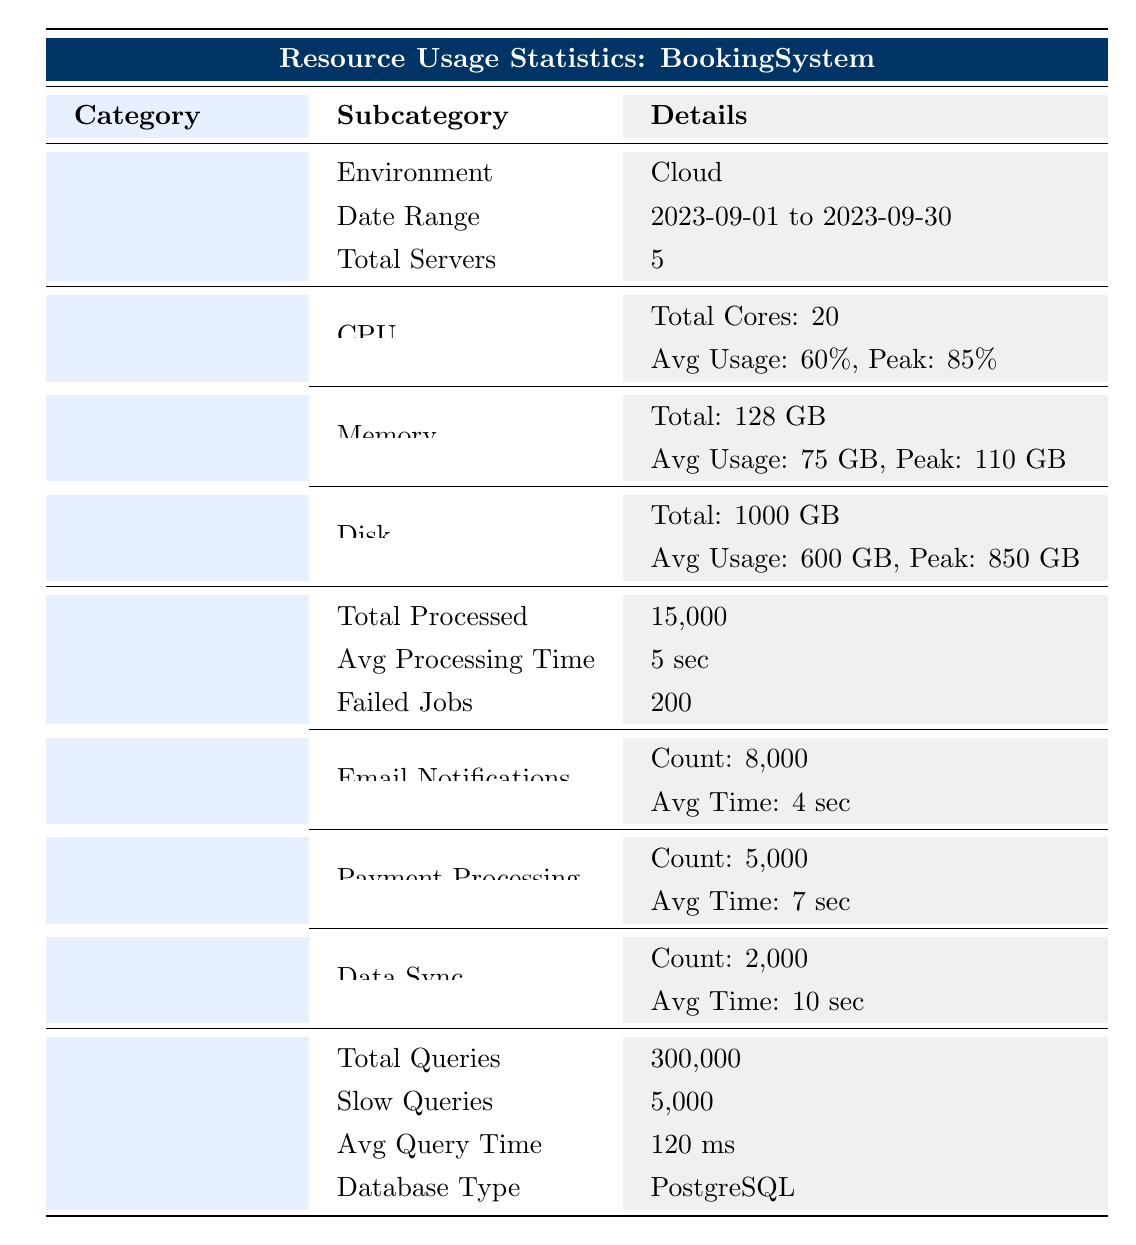What is the total number of servers used in the BookingSystem application? The table states under the "General Info" section that there are a total of 5 servers employed in the BookingSystem application.
Answer: 5 What is the average CPU usage in the BookingSystem application during September 2023? From the "Server Stats" section, the average CPU usage is displayed as 60%.
Answer: 60% How many failed background jobs were recorded? The table indicates in the "Background Jobs" section that there were 200 failed jobs throughout September 2023.
Answer: 200 What is the total memory usage in GB when peak memory usage is 110 GB and average memory usage is 75 GB? The peak usage is provided as 110 GB while the average usage is 75 GB. Since the question does not require combining these values, the answer is only about the peak usage noted in the table.
Answer: 110 Is the database type used in the BookingSystem application PostgreSQL? The "Database Stats" section confirms that the database type is specified as PostgreSQL.
Answer: Yes What is the total number of emails processed as background jobs? The "Job Types" section shows that the count for Email Notifications is 8000. Thus, this is the total number of emails processed.
Answer: 8000 What percentage of queries were slow based on the total queries and slow queries? The slow queries count is 5000, and total queries are 300000. Therefore, the percentage of slow queries is (5000 / 300000) * 100 = 1.67%. This requires calculating the ratio of slow queries to total queries.
Answer: 1.67% What is the average processing time for all background jobs? The average processing time for background jobs is mentioned in the table as 5 seconds, which is straightforward as found in the "Background Jobs" section.
Answer: 5 seconds Which job type took the longest average processing time? By comparing the average processing times across the job types listed in the "Job Types" section, Data Sync has the longest average processing time at 10 seconds.
Answer: Data Sync What is the peak disk usage in GB during September 2023? The "Disk" section in the "Server Stats" indicates that the peak usage recorded is 850 GB.
Answer: 850 GB 